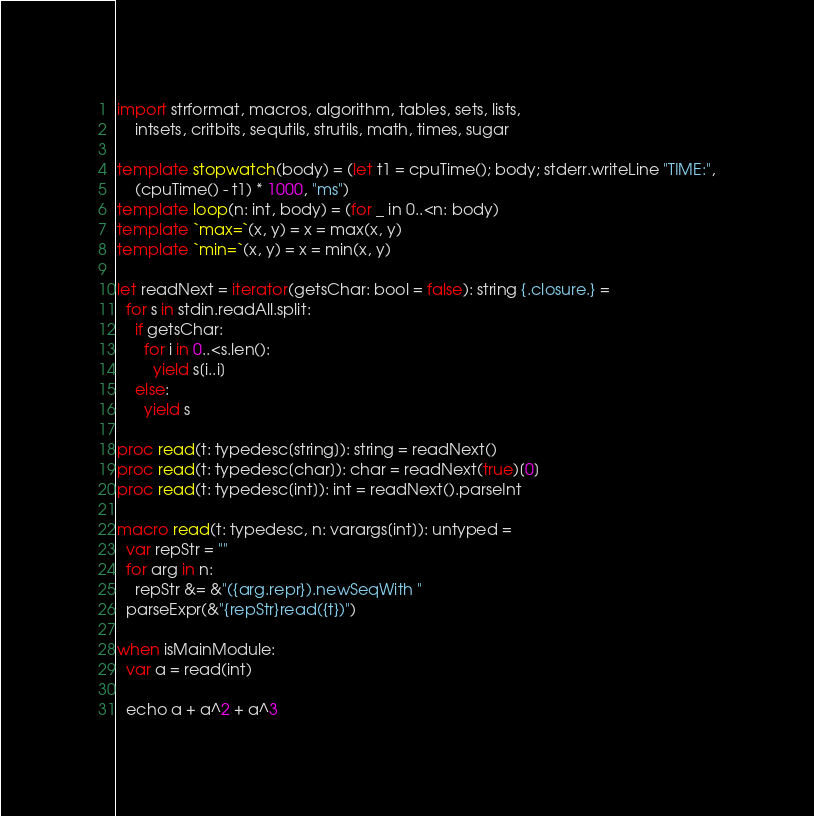Convert code to text. <code><loc_0><loc_0><loc_500><loc_500><_Nim_>import strformat, macros, algorithm, tables, sets, lists,
    intsets, critbits, sequtils, strutils, math, times, sugar

template stopwatch(body) = (let t1 = cpuTime(); body; stderr.writeLine "TIME:",
    (cpuTime() - t1) * 1000, "ms")
template loop(n: int, body) = (for _ in 0..<n: body)
template `max=`(x, y) = x = max(x, y)
template `min=`(x, y) = x = min(x, y)

let readNext = iterator(getsChar: bool = false): string {.closure.} =
  for s in stdin.readAll.split:
    if getsChar:
      for i in 0..<s.len():
        yield s[i..i]
    else:
      yield s

proc read(t: typedesc[string]): string = readNext()
proc read(t: typedesc[char]): char = readNext(true)[0]
proc read(t: typedesc[int]): int = readNext().parseInt

macro read(t: typedesc, n: varargs[int]): untyped =
  var repStr = ""
  for arg in n:
    repStr &= &"({arg.repr}).newSeqWith "
  parseExpr(&"{repStr}read({t})")

when isMainModule:
  var a = read(int)

  echo a + a^2 + a^3
</code> 